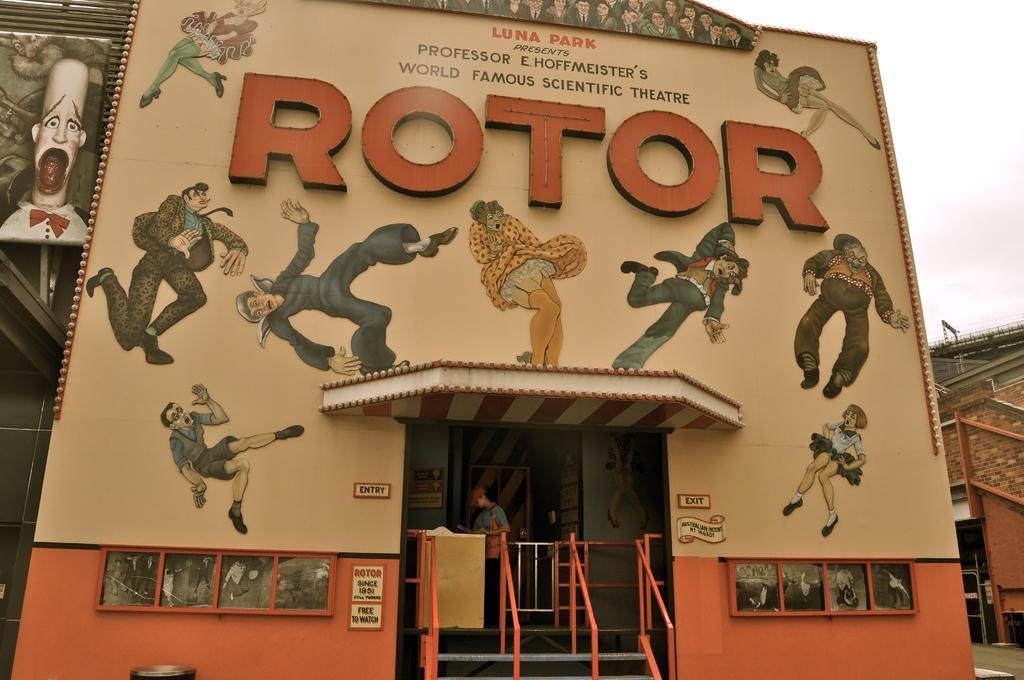Please provide a concise description of this image. This image consists of building. There is a man at the bottom. There are stairs at the bottom. There is sky at the top. 